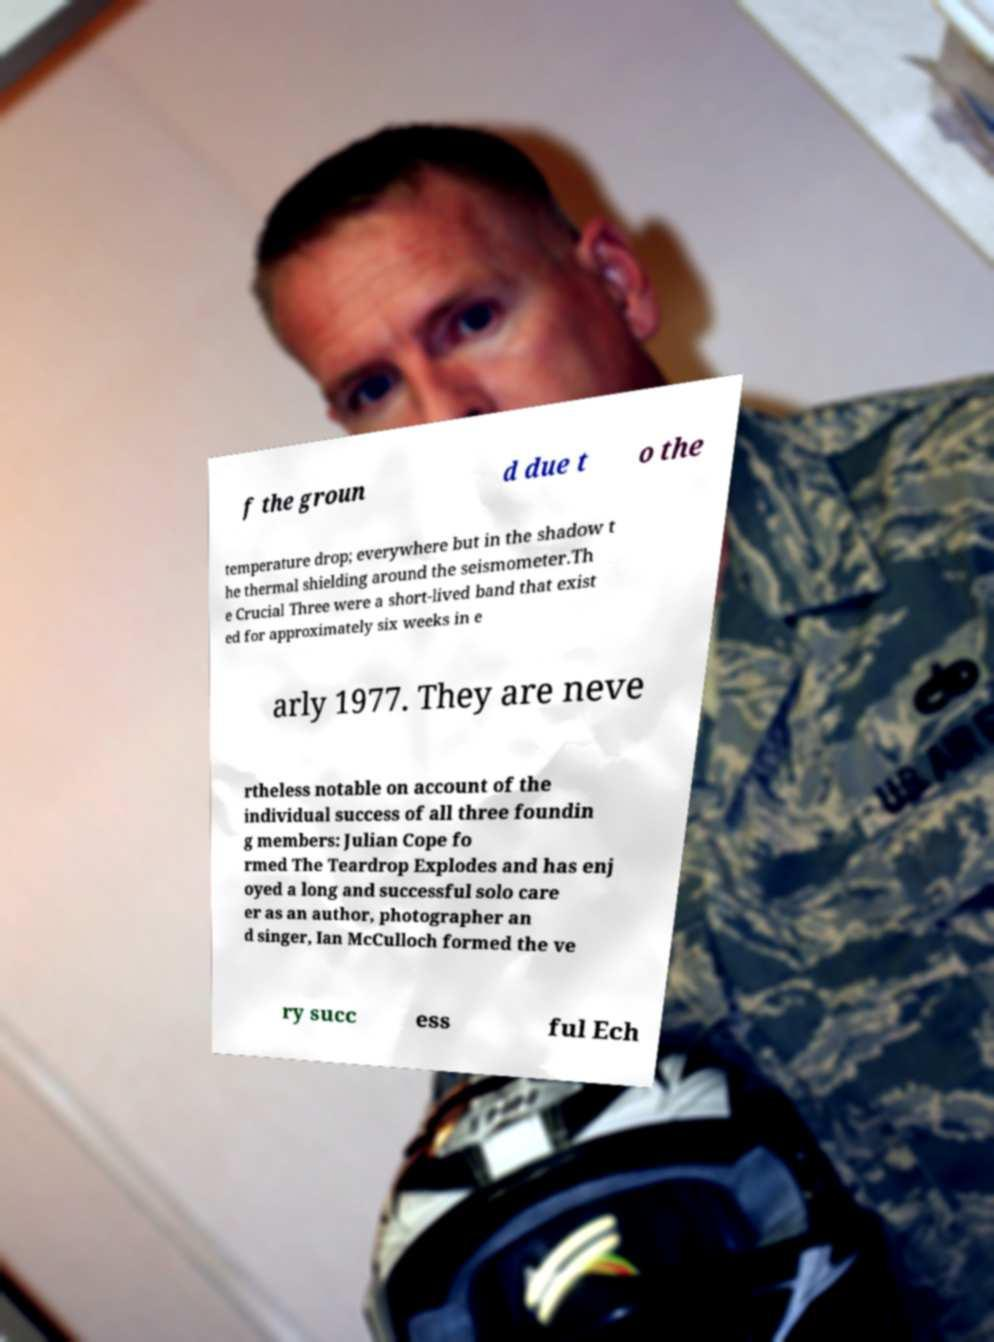For documentation purposes, I need the text within this image transcribed. Could you provide that? f the groun d due t o the temperature drop; everywhere but in the shadow t he thermal shielding around the seismometer.Th e Crucial Three were a short-lived band that exist ed for approximately six weeks in e arly 1977. They are neve rtheless notable on account of the individual success of all three foundin g members: Julian Cope fo rmed The Teardrop Explodes and has enj oyed a long and successful solo care er as an author, photographer an d singer, Ian McCulloch formed the ve ry succ ess ful Ech 